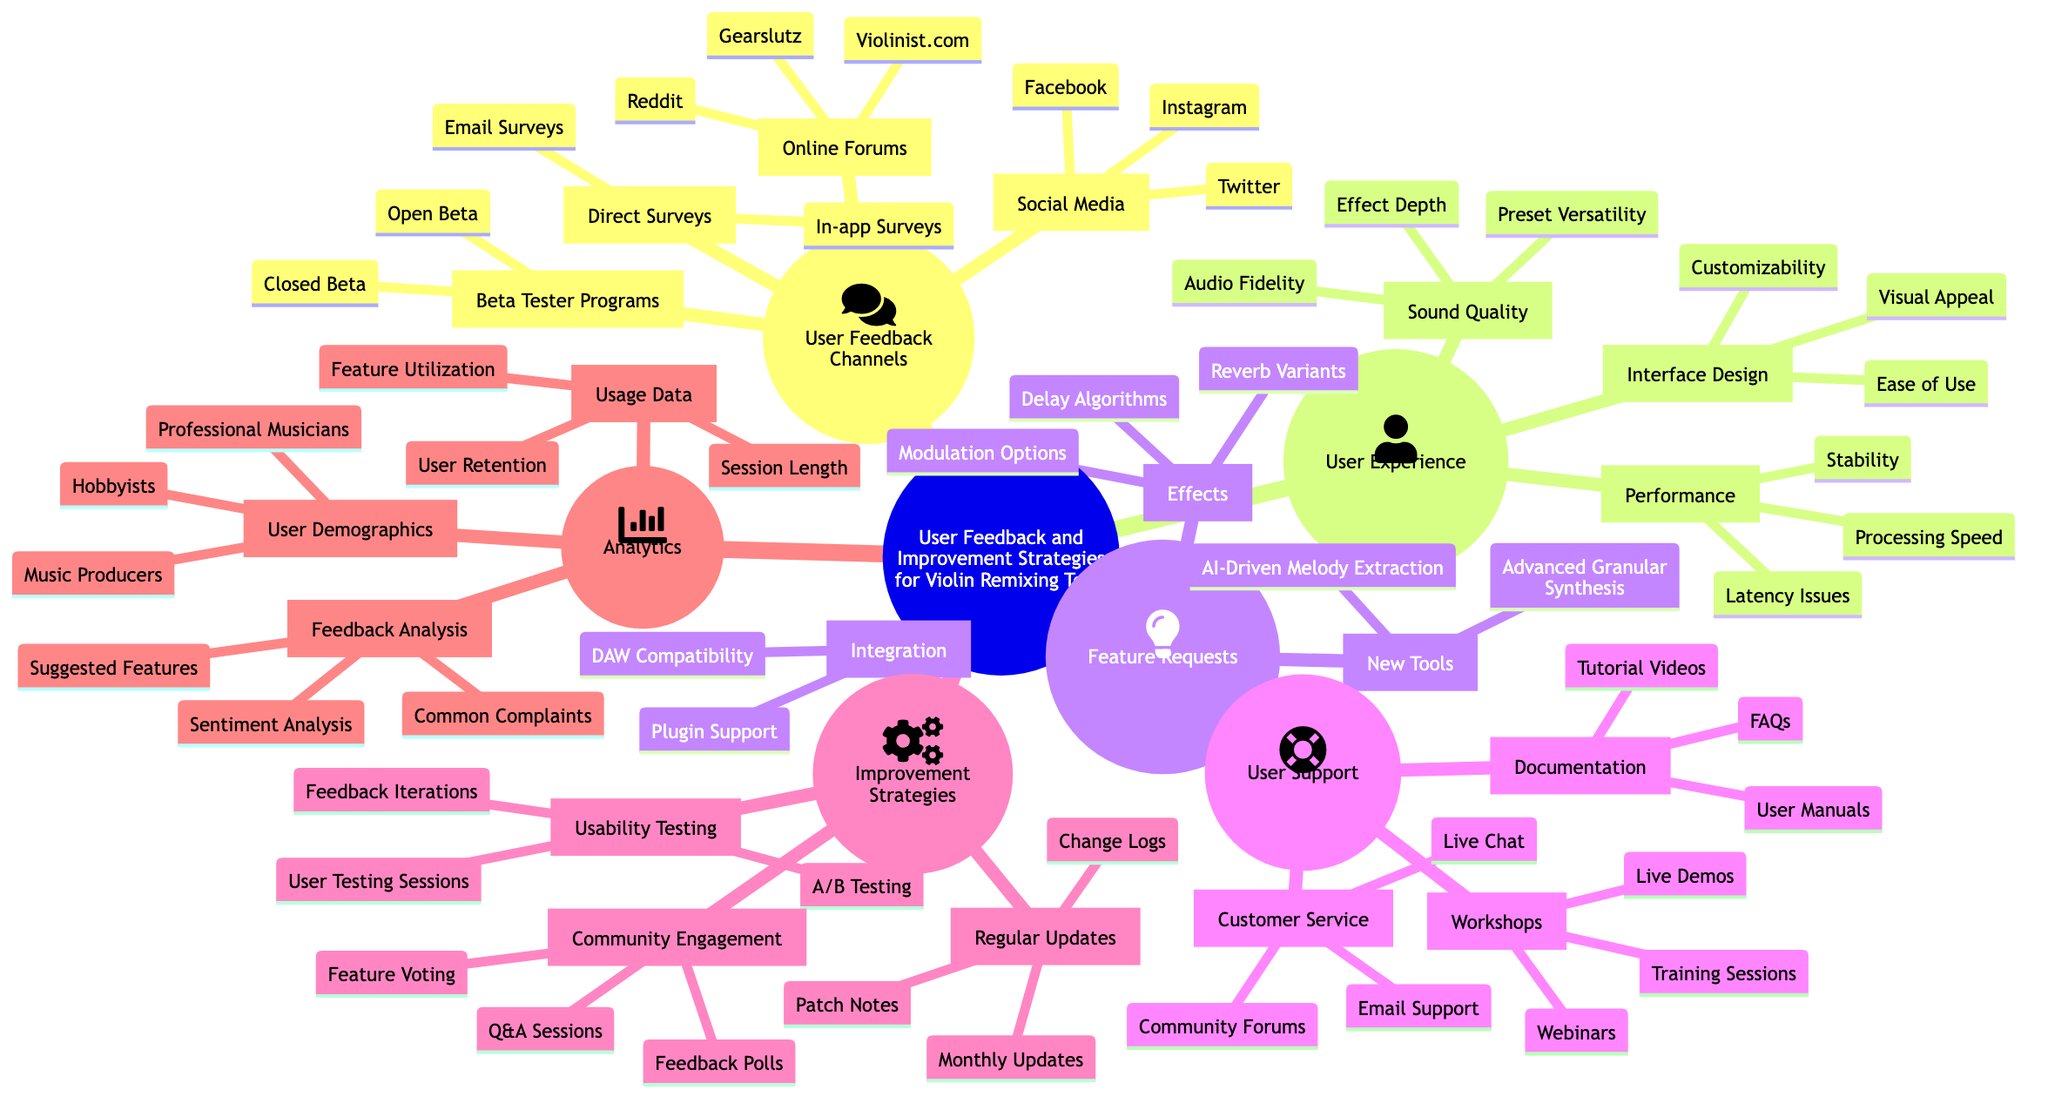What are two user feedback channels listed in the diagram? The diagram lists "Online Forums" and "Social Media" as user feedback channels. These can be found under the "User Feedback Channels" section.
Answer: Online Forums, Social Media How many user support options are mentioned in the diagram? The diagram breaks down user support into three categories: Documentation, Customer Service, and Workshops. This means there are three main support options presented.
Answer: 3 What strategy involves "User Testing Sessions"? "Usability Testing" is the strategy that includes "User Testing Sessions" according to the diagram. You can find this under the "Improvement Strategies" section.
Answer: Usability Testing Which type of users is mentioned as part of user demographics? The diagram includes "Professional Musicians" as one of the user demographics listed under the "User Demographics" category in the "Analytics" section.
Answer: Professional Musicians What is one new tool requested in the diagram? The diagram specifies "AI-Driven Melody Extraction" as one of the new tools requested under the "Feature Requests" category.
Answer: AI-Driven Melody Extraction How many integration aspects are listed under feature requests? There are two integration aspects mentioned: "DAW Compatibility" and "Plugin Support" found under the "Integration" section in the "Feature Requests."
Answer: 2 What is the purpose of "Feedback Polls"? "Feedback Polls" are part of the "Community Engagement" strategies aimed at collecting user opinions and suggestions for improvements or new features.
Answer: Collecting user opinions Which aspect of user experience addresses "Latency Issues"? "Performance" addresses "Latency Issues," as shown in the "User Experience" section of the diagram, indicating how tools operate under various conditions.
Answer: Performance What type of analytics involves studying "Common Complaints"? "Feedback Analysis" involves studying "Common Complaints" according to the "Analytics" section, which focuses on evaluating user feedback.
Answer: Feedback Analysis 